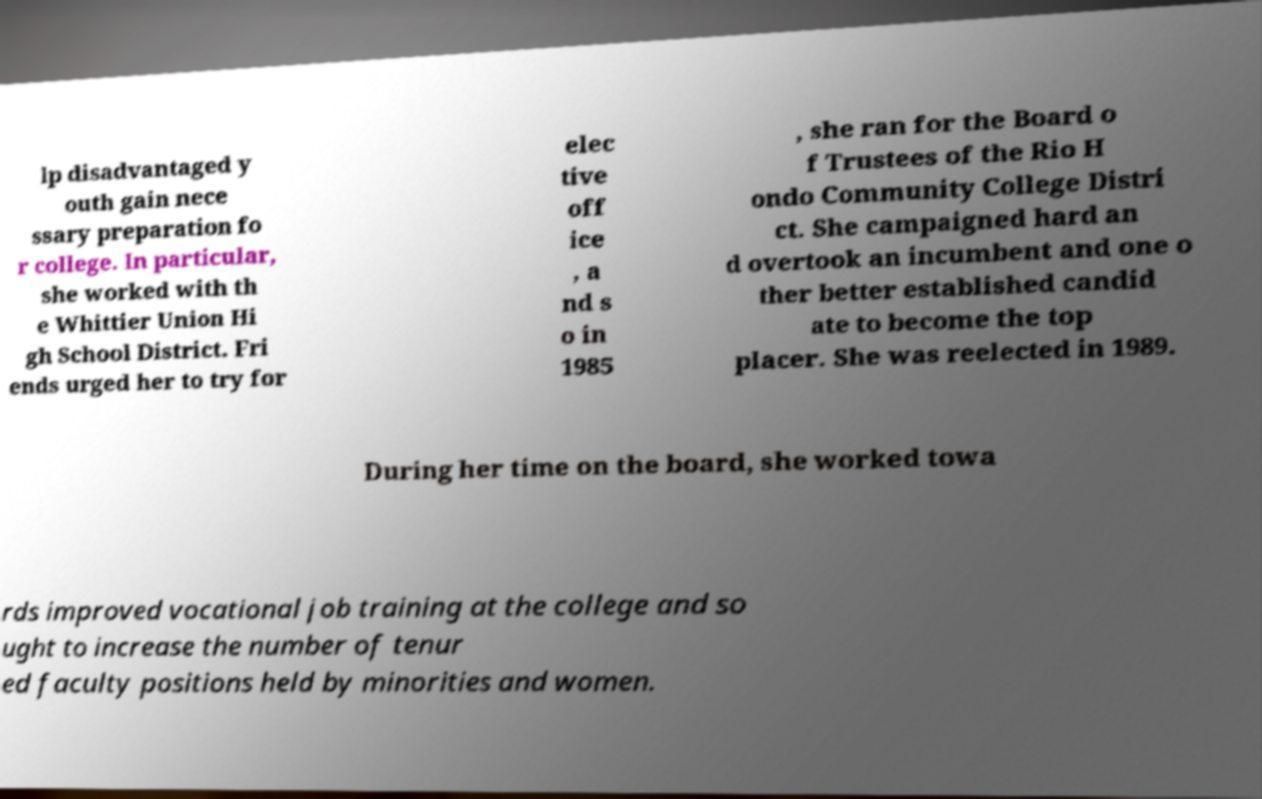Could you extract and type out the text from this image? lp disadvantaged y outh gain nece ssary preparation fo r college. In particular, she worked with th e Whittier Union Hi gh School District. Fri ends urged her to try for elec tive off ice , a nd s o in 1985 , she ran for the Board o f Trustees of the Rio H ondo Community College Distri ct. She campaigned hard an d overtook an incumbent and one o ther better established candid ate to become the top placer. She was reelected in 1989. During her time on the board, she worked towa rds improved vocational job training at the college and so ught to increase the number of tenur ed faculty positions held by minorities and women. 